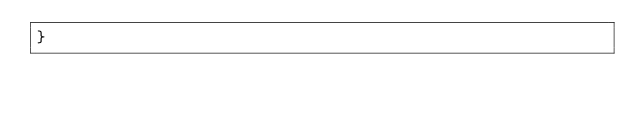<code> <loc_0><loc_0><loc_500><loc_500><_CSS_>}
</code> 